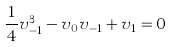Convert formula to latex. <formula><loc_0><loc_0><loc_500><loc_500>\frac { 1 } { 4 } v _ { - 1 } ^ { 3 } - v _ { 0 } v _ { - 1 } + v _ { 1 } = 0</formula> 